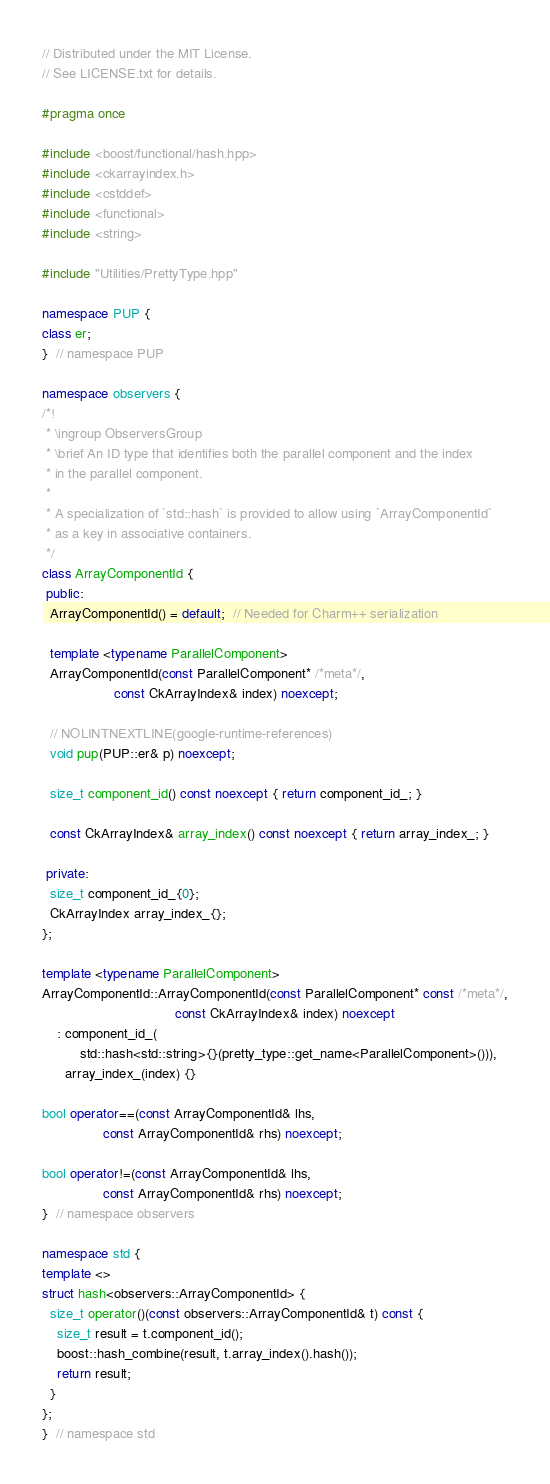Convert code to text. <code><loc_0><loc_0><loc_500><loc_500><_C++_>// Distributed under the MIT License.
// See LICENSE.txt for details.

#pragma once

#include <boost/functional/hash.hpp>
#include <ckarrayindex.h>
#include <cstddef>
#include <functional>
#include <string>

#include "Utilities/PrettyType.hpp"

namespace PUP {
class er;
}  // namespace PUP

namespace observers {
/*!
 * \ingroup ObserversGroup
 * \brief An ID type that identifies both the parallel component and the index
 * in the parallel component.
 *
 * A specialization of `std::hash` is provided to allow using `ArrayComponentId`
 * as a key in associative containers.
 */
class ArrayComponentId {
 public:
  ArrayComponentId() = default;  // Needed for Charm++ serialization

  template <typename ParallelComponent>
  ArrayComponentId(const ParallelComponent* /*meta*/,
                   const CkArrayIndex& index) noexcept;

  // NOLINTNEXTLINE(google-runtime-references)
  void pup(PUP::er& p) noexcept;

  size_t component_id() const noexcept { return component_id_; }

  const CkArrayIndex& array_index() const noexcept { return array_index_; }

 private:
  size_t component_id_{0};
  CkArrayIndex array_index_{};
};

template <typename ParallelComponent>
ArrayComponentId::ArrayComponentId(const ParallelComponent* const /*meta*/,
                                   const CkArrayIndex& index) noexcept
    : component_id_(
          std::hash<std::string>{}(pretty_type::get_name<ParallelComponent>())),
      array_index_(index) {}

bool operator==(const ArrayComponentId& lhs,
                const ArrayComponentId& rhs) noexcept;

bool operator!=(const ArrayComponentId& lhs,
                const ArrayComponentId& rhs) noexcept;
}  // namespace observers

namespace std {
template <>
struct hash<observers::ArrayComponentId> {
  size_t operator()(const observers::ArrayComponentId& t) const {
    size_t result = t.component_id();
    boost::hash_combine(result, t.array_index().hash());
    return result;
  }
};
}  // namespace std
</code> 